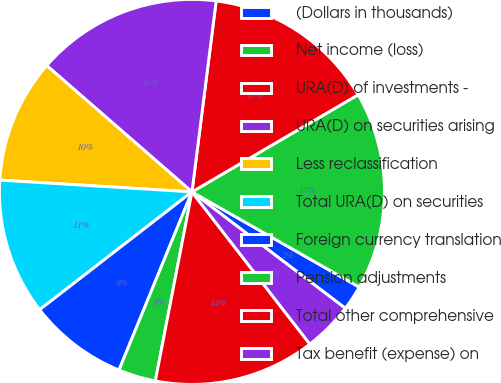Convert chart. <chart><loc_0><loc_0><loc_500><loc_500><pie_chart><fcel>(Dollars in thousands)<fcel>Net income (loss)<fcel>URA(D) of investments -<fcel>URA(D) on securities arising<fcel>Less reclassification<fcel>Total URA(D) on securities<fcel>Foreign currency translation<fcel>Pension adjustments<fcel>Total other comprehensive<fcel>Tax benefit (expense) on<nl><fcel>2.1%<fcel>16.66%<fcel>14.58%<fcel>15.62%<fcel>10.42%<fcel>11.46%<fcel>8.34%<fcel>3.14%<fcel>13.54%<fcel>4.18%<nl></chart> 